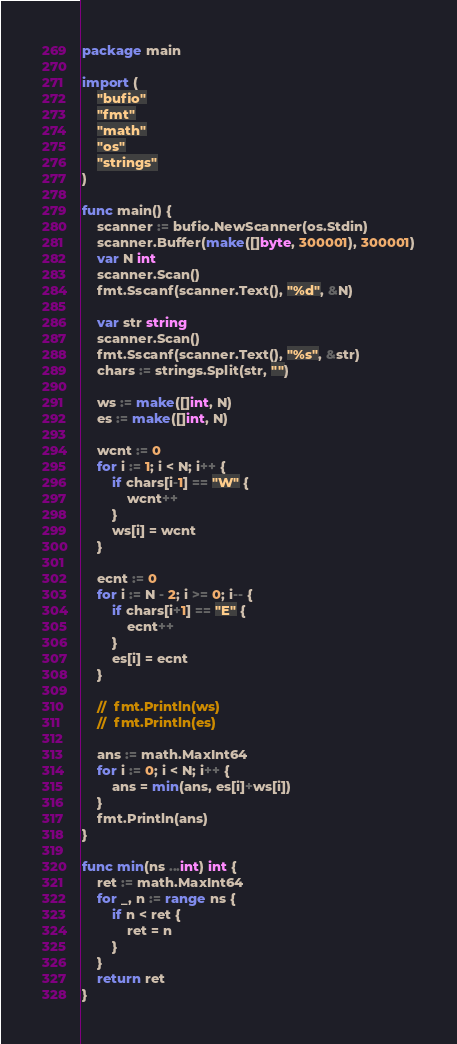<code> <loc_0><loc_0><loc_500><loc_500><_Go_>package main

import (
	"bufio"
	"fmt"
	"math"
	"os"
	"strings"
)

func main() {
	scanner := bufio.NewScanner(os.Stdin)
	scanner.Buffer(make([]byte, 300001), 300001)
	var N int
	scanner.Scan()
	fmt.Sscanf(scanner.Text(), "%d", &N)

	var str string
	scanner.Scan()
	fmt.Sscanf(scanner.Text(), "%s", &str)
	chars := strings.Split(str, "")

	ws := make([]int, N)
	es := make([]int, N)

	wcnt := 0
	for i := 1; i < N; i++ {
		if chars[i-1] == "W" {
			wcnt++
		}
		ws[i] = wcnt
	}

	ecnt := 0
	for i := N - 2; i >= 0; i-- {
		if chars[i+1] == "E" {
			ecnt++
		}
		es[i] = ecnt
	}

	//	fmt.Println(ws)
	//  fmt.Println(es)

	ans := math.MaxInt64
	for i := 0; i < N; i++ {
		ans = min(ans, es[i]+ws[i])
	}
	fmt.Println(ans)
}

func min(ns ...int) int {
	ret := math.MaxInt64
	for _, n := range ns {
		if n < ret {
			ret = n
		}
	}
	return ret
}
</code> 